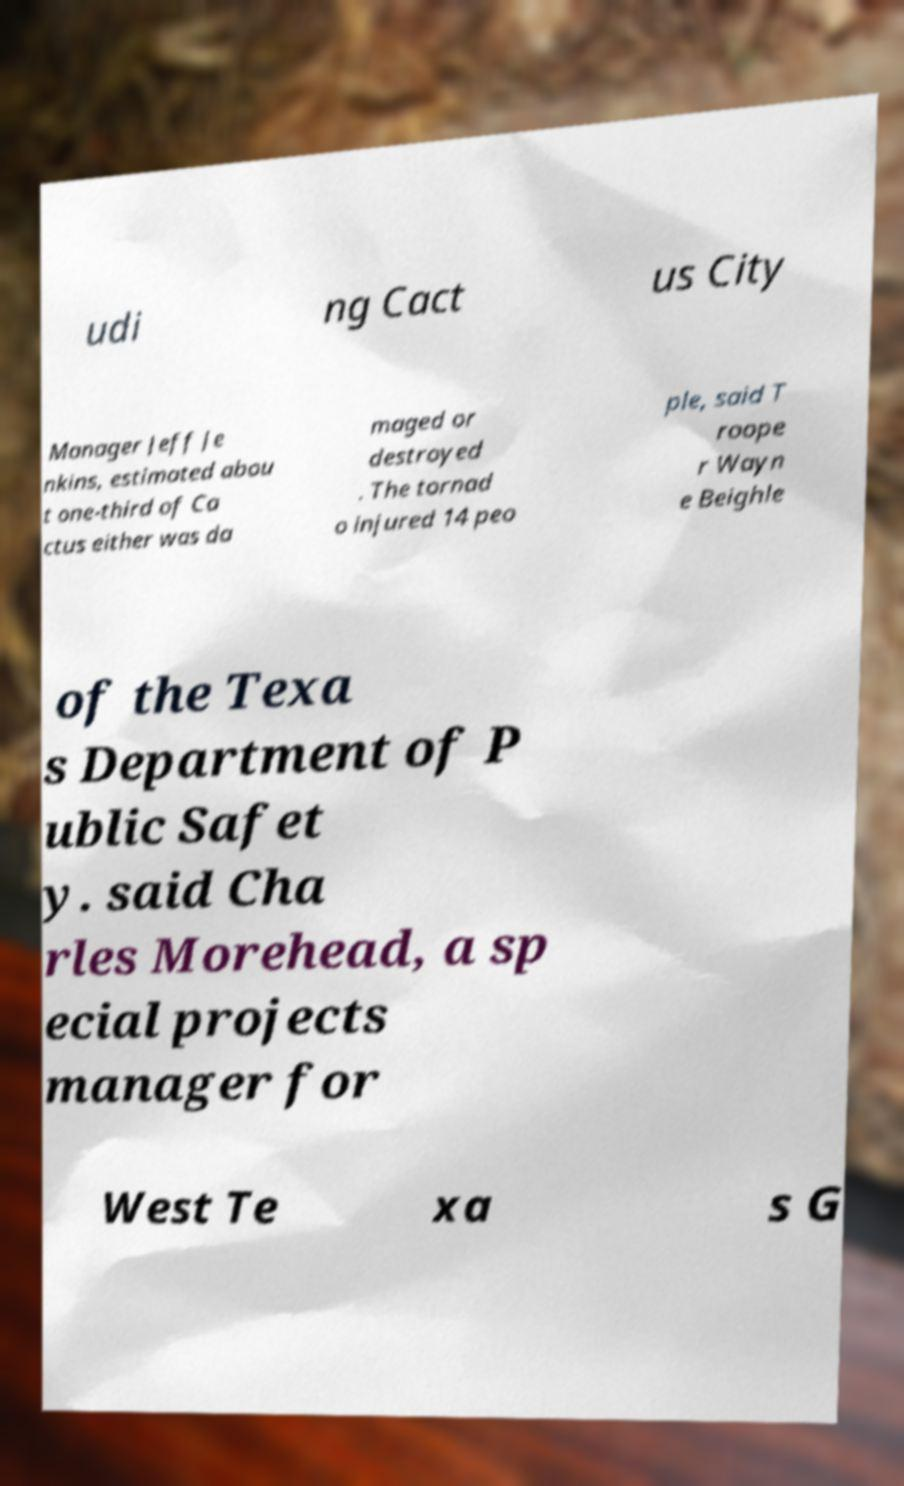Can you accurately transcribe the text from the provided image for me? udi ng Cact us City Manager Jeff Je nkins, estimated abou t one-third of Ca ctus either was da maged or destroyed . The tornad o injured 14 peo ple, said T roope r Wayn e Beighle of the Texa s Department of P ublic Safet y. said Cha rles Morehead, a sp ecial projects manager for West Te xa s G 